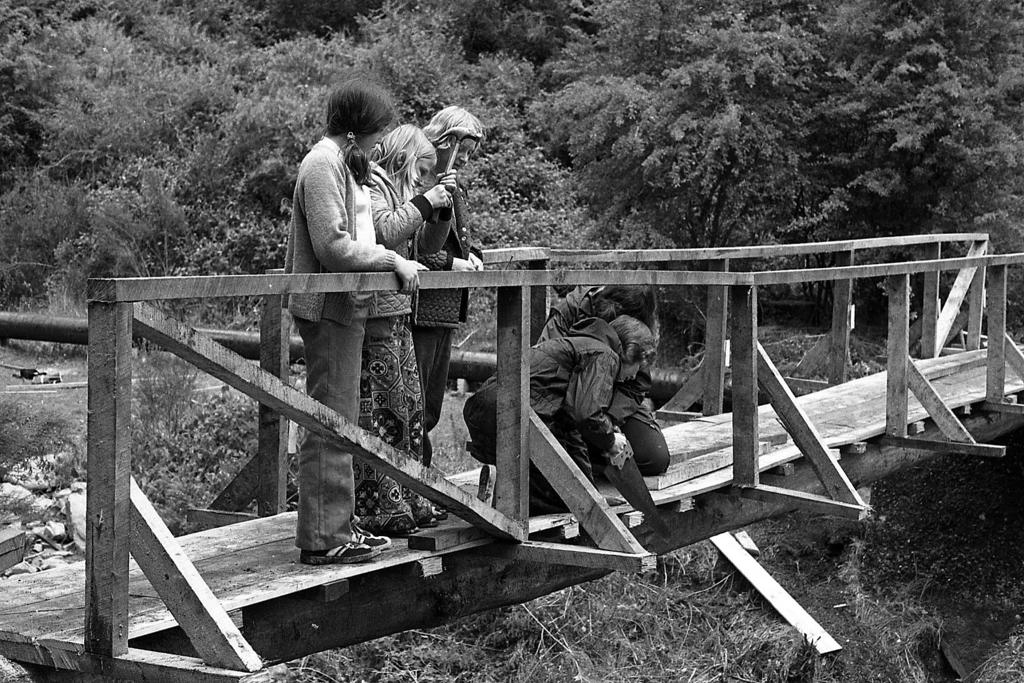What are the persons in the image standing on? The persons in the image are standing on a wooden bridge. What feature does the wooden bridge have? The wooden bridge has a fence. What activity is one of the persons engaged in? One person is sawing wood with a hand saw. What can be seen in the background of the image? There are plants and trees in the background of the image. What type of oven is visible in the image? There is no oven present in the image. Can you tell me which actor is standing on the wooden bridge? The image does not depict any actors; it shows persons who are likely not actors. 